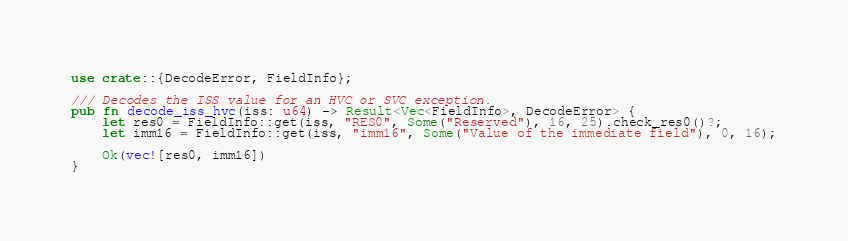Convert code to text. <code><loc_0><loc_0><loc_500><loc_500><_Rust_>
use crate::{DecodeError, FieldInfo};

/// Decodes the ISS value for an HVC or SVC exception.
pub fn decode_iss_hvc(iss: u64) -> Result<Vec<FieldInfo>, DecodeError> {
    let res0 = FieldInfo::get(iss, "RES0", Some("Reserved"), 16, 25).check_res0()?;
    let imm16 = FieldInfo::get(iss, "imm16", Some("Value of the immediate field"), 0, 16);

    Ok(vec![res0, imm16])
}
</code> 